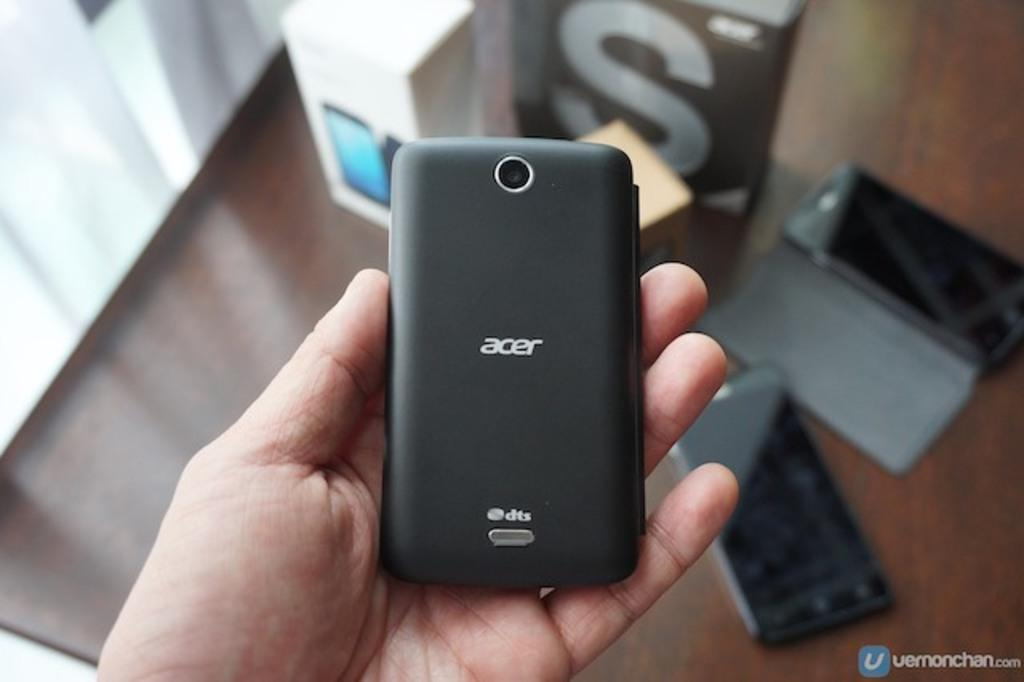Provide a one-sentence caption for the provided image. A hand holding an Acer phone above a desk. 